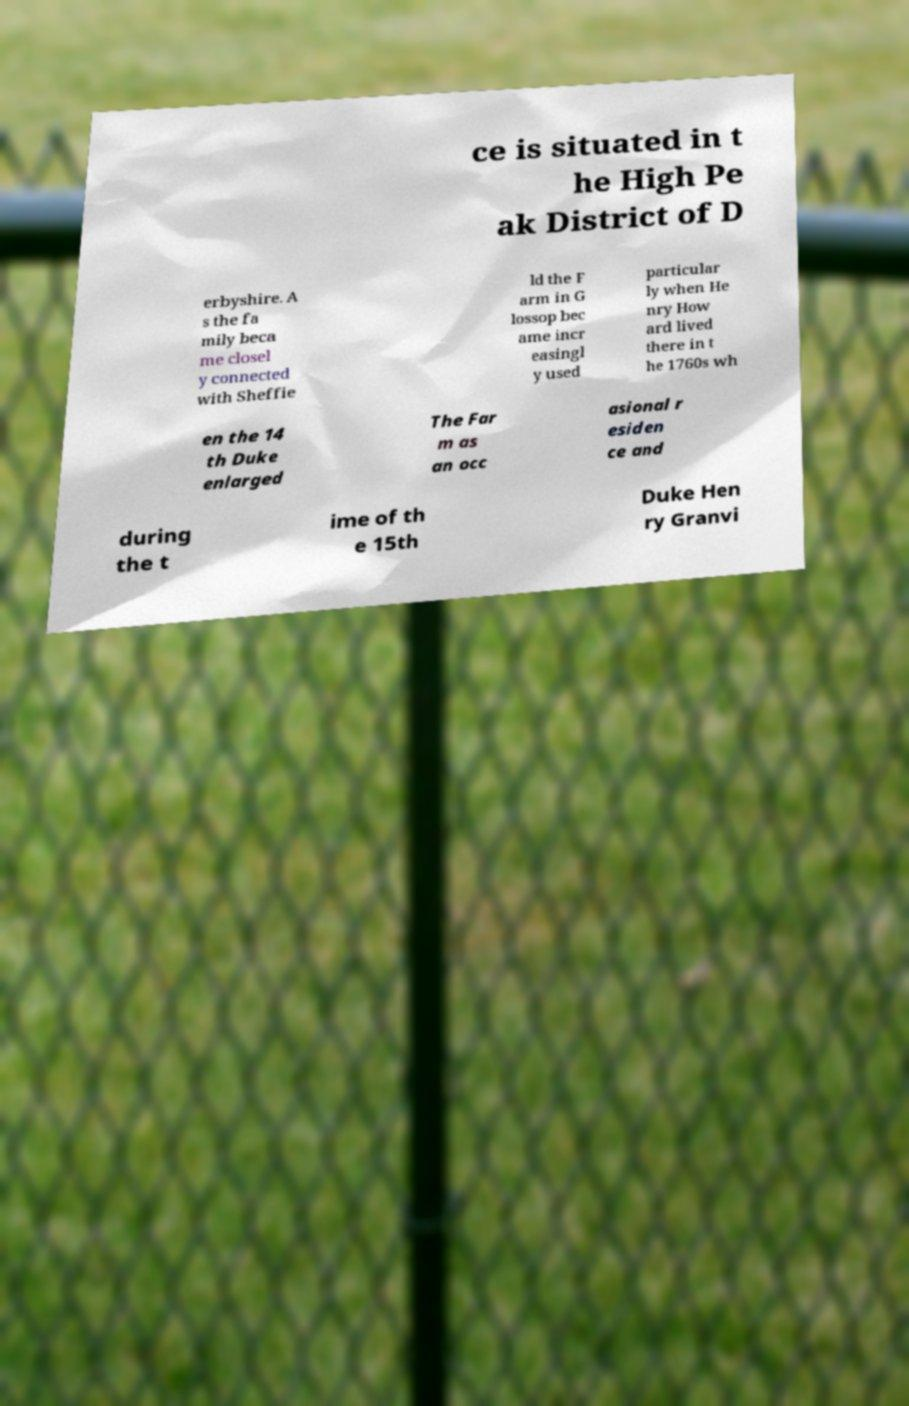Please identify and transcribe the text found in this image. ce is situated in t he High Pe ak District of D erbyshire. A s the fa mily beca me closel y connected with Sheffie ld the F arm in G lossop bec ame incr easingl y used particular ly when He nry How ard lived there in t he 1760s wh en the 14 th Duke enlarged The Far m as an occ asional r esiden ce and during the t ime of th e 15th Duke Hen ry Granvi 